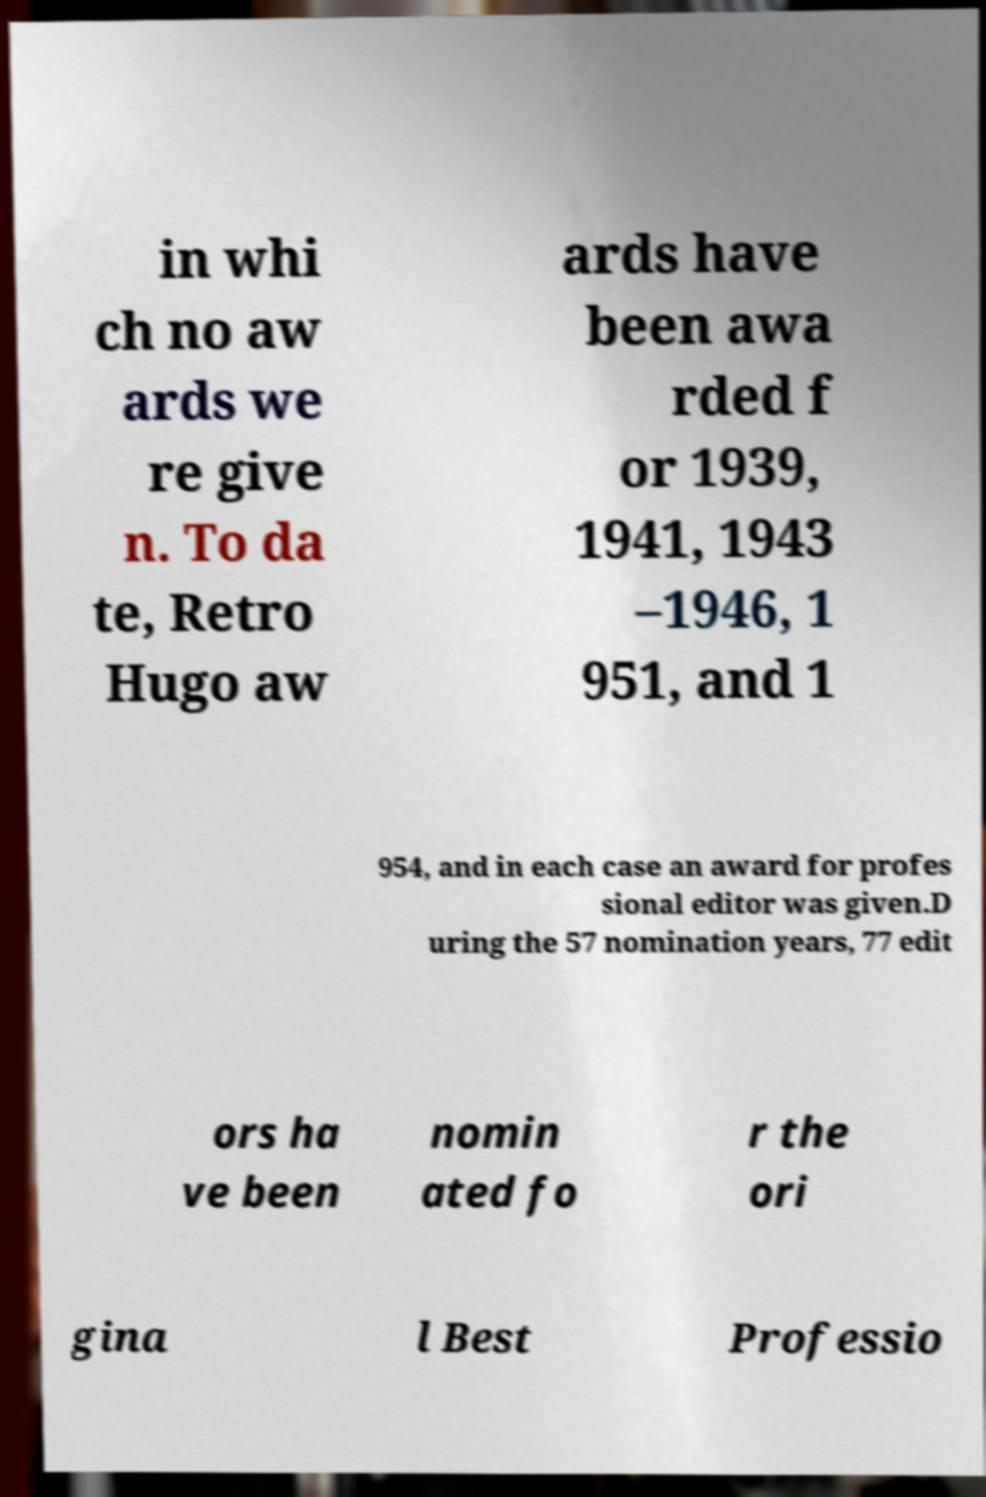I need the written content from this picture converted into text. Can you do that? in whi ch no aw ards we re give n. To da te, Retro Hugo aw ards have been awa rded f or 1939, 1941, 1943 –1946, 1 951, and 1 954, and in each case an award for profes sional editor was given.D uring the 57 nomination years, 77 edit ors ha ve been nomin ated fo r the ori gina l Best Professio 